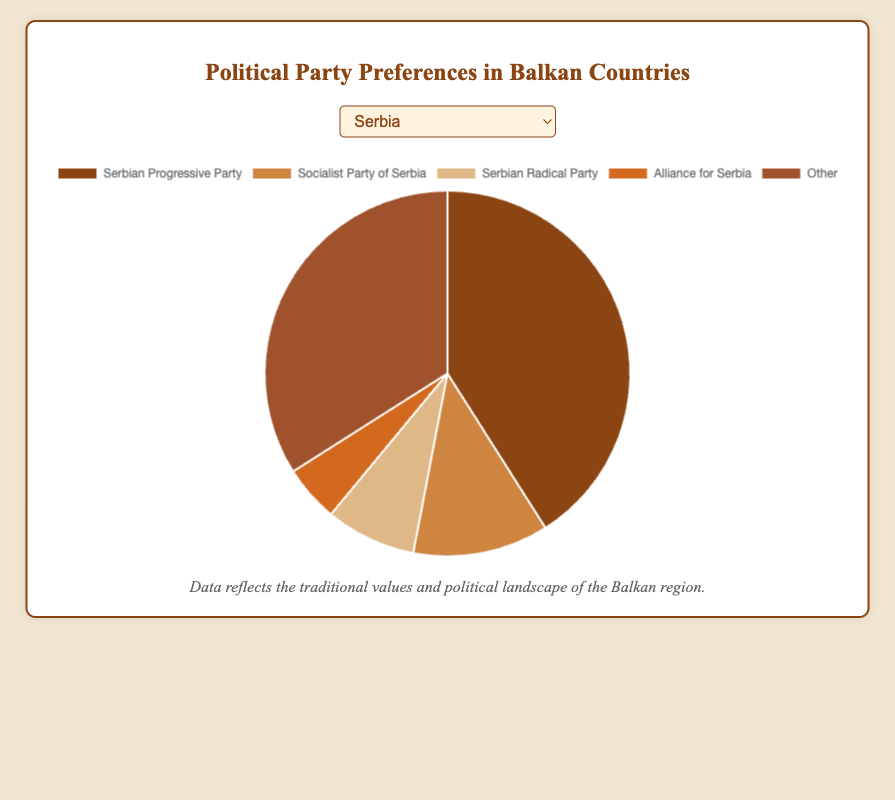Which party has the highest support percentage in Serbia? The pie chart for Serbia shows the percentage of support for different political parties. The largest section corresponds to the Serbian Progressive Party with 41%.
Answer: Serbian Progressive Party What is the combined support percentage of the two most popular parties in North Macedonia? The pie chart for North Macedonia indicates that VMRO-DPMNE has 25% and the Social Democratic Union of Macedonia has 23%. Adding these together gives 25% + 23% = 48%.
Answer: 48% How does the support percentage for the Homeland Movement in Croatia compare to the Serbian Radical Party in Serbia? Referencing the charts, the Homeland Movement in Croatia has 9% support whereas the Serbian Radical Party in Serbia has 8%. 9% is greater than 8%.
Answer: Homeland Movement has more support Which country has the highest combined 'Other' category percentage? Examining each chart, the 'Other' category is 34% in Serbia, 29% in Croatia, 38% in Bosnia and Herzegovina, and 29% in North Macedonia. The highest percentage is 38% from Bosnia and Herzegovina.
Answer: Bosnia and Herzegovina Is the Socialist Party of Serbia more or less popular than the Bridge of Independent Lists in Croatia? The pie chart for Serbia shows the Socialist Party of Serbia has 12% support. The pie chart for Croatia shows the Bridge of Independent Lists has 11%.
Answer: More popular What is the difference in support percentage between the Croatian Democratic Union and the Social Democratic Party of Croatia? The pie chart for Croatia shows the Croatian Democratic Union has 27% and the Social Democratic Party of Croatia has 24%. The difference is 27% - 24% = 3%.
Answer: 3% What is the total percentage of support for the top three parties in Bosnia and Herzegovina? The pie chart for Bosnia and Herzegovina indicates the Party of Democratic Action has 22%, the Serb Democratic Party has 15%, and the Croatian Democratic Union of Bosnia and Herzegovina has 14%. The total is 22% + 15% + 14% = 51%.
Answer: 51% List the parties with more than 20% support in any country and their respective countries. Each chart has sections indicating which parties have more than 20%. Serbian Progressive Party (Serbia) has 41%, Croatian Democratic Union (Croatia) has 27%, Social Democratic Party of Croatia (Croatia) has 24%, VMRO-DPMNE (North Macedonia) has 25%, and Social Democratic Union of Macedonia (North Macedonia) has 23%.
Answer: Serbian Progressive Party (Serbia), Croatian Democratic Union (Croatia), Social Democratic Party of Croatia (Croatia), VMRO-DPMNE (North Macedonia), Social Democratic Union of Macedonia (North Macedonia) What share of the votes does the third largest party receive in North Macedonia? The pie chart for North Macedonia shows the largest party is VMRO-DPMNE with 25%, followed by the Social Democratic Union of Macedonia with 23%, and the third largest is the Democratic Union for Integration with 15%.
Answer: 15% 